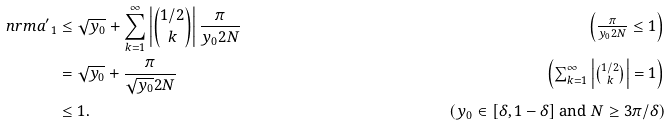Convert formula to latex. <formula><loc_0><loc_0><loc_500><loc_500>\ n r m { a ^ { \prime } } _ { 1 } & \leq \sqrt { y _ { 0 } } + \sum _ { k = 1 } ^ { \infty } \left | \binom { 1 / 2 } { k } \right | \frac { \pi } { y _ { 0 } 2 N } \tag* { $ \left ( \frac { \pi } { y _ { 0 } 2 N } \leq 1 \right ) $ } \\ & = \sqrt { y _ { 0 } } + \frac { \pi } { \sqrt { y _ { 0 } } 2 N } \tag* { $ \left ( \sum _ { k = 1 } ^ { \infty } \left | \binom { 1 / 2 } { k } \right | = 1 \right ) $ } \\ & \leq 1 . \tag* { $ \left ( y _ { 0 } \in [ \delta , 1 - \delta ] \text { and } N \geq 3 \pi / \delta \right ) $ }</formula> 